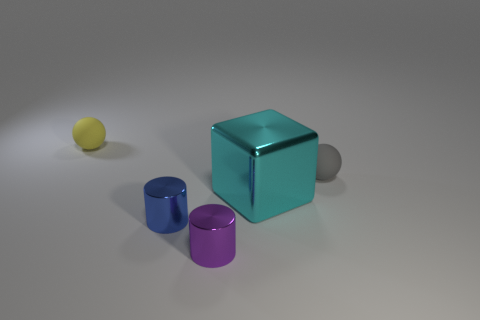There is a rubber thing on the left side of the tiny cylinder on the right side of the small shiny object behind the tiny purple metallic cylinder; what size is it?
Your response must be concise. Small. Is the size of the gray matte sphere the same as the cyan block?
Offer a very short reply. No. Do the small matte object that is to the left of the small gray rubber thing and the matte object that is in front of the yellow thing have the same shape?
Your response must be concise. Yes. There is a matte thing that is right of the cyan metallic object; is there a blue thing that is behind it?
Ensure brevity in your answer.  No. Are there any big shiny things?
Your answer should be very brief. Yes. What number of purple objects are the same size as the purple metal cylinder?
Your answer should be compact. 0. What number of tiny things are to the left of the big cyan cube and behind the purple cylinder?
Your response must be concise. 2. There is a object that is behind the gray rubber object; does it have the same size as the purple metallic cylinder?
Make the answer very short. Yes. Are there any metal cubes of the same color as the big thing?
Your answer should be very brief. No. What size is the cyan object that is the same material as the tiny blue object?
Your answer should be compact. Large. 